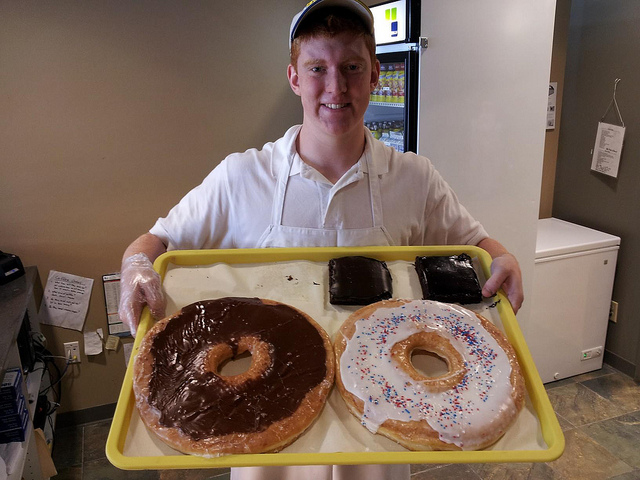How does the size of the items on the tray compare to the typical item of this type?
Answer the question using a single word or phrase. Larger 